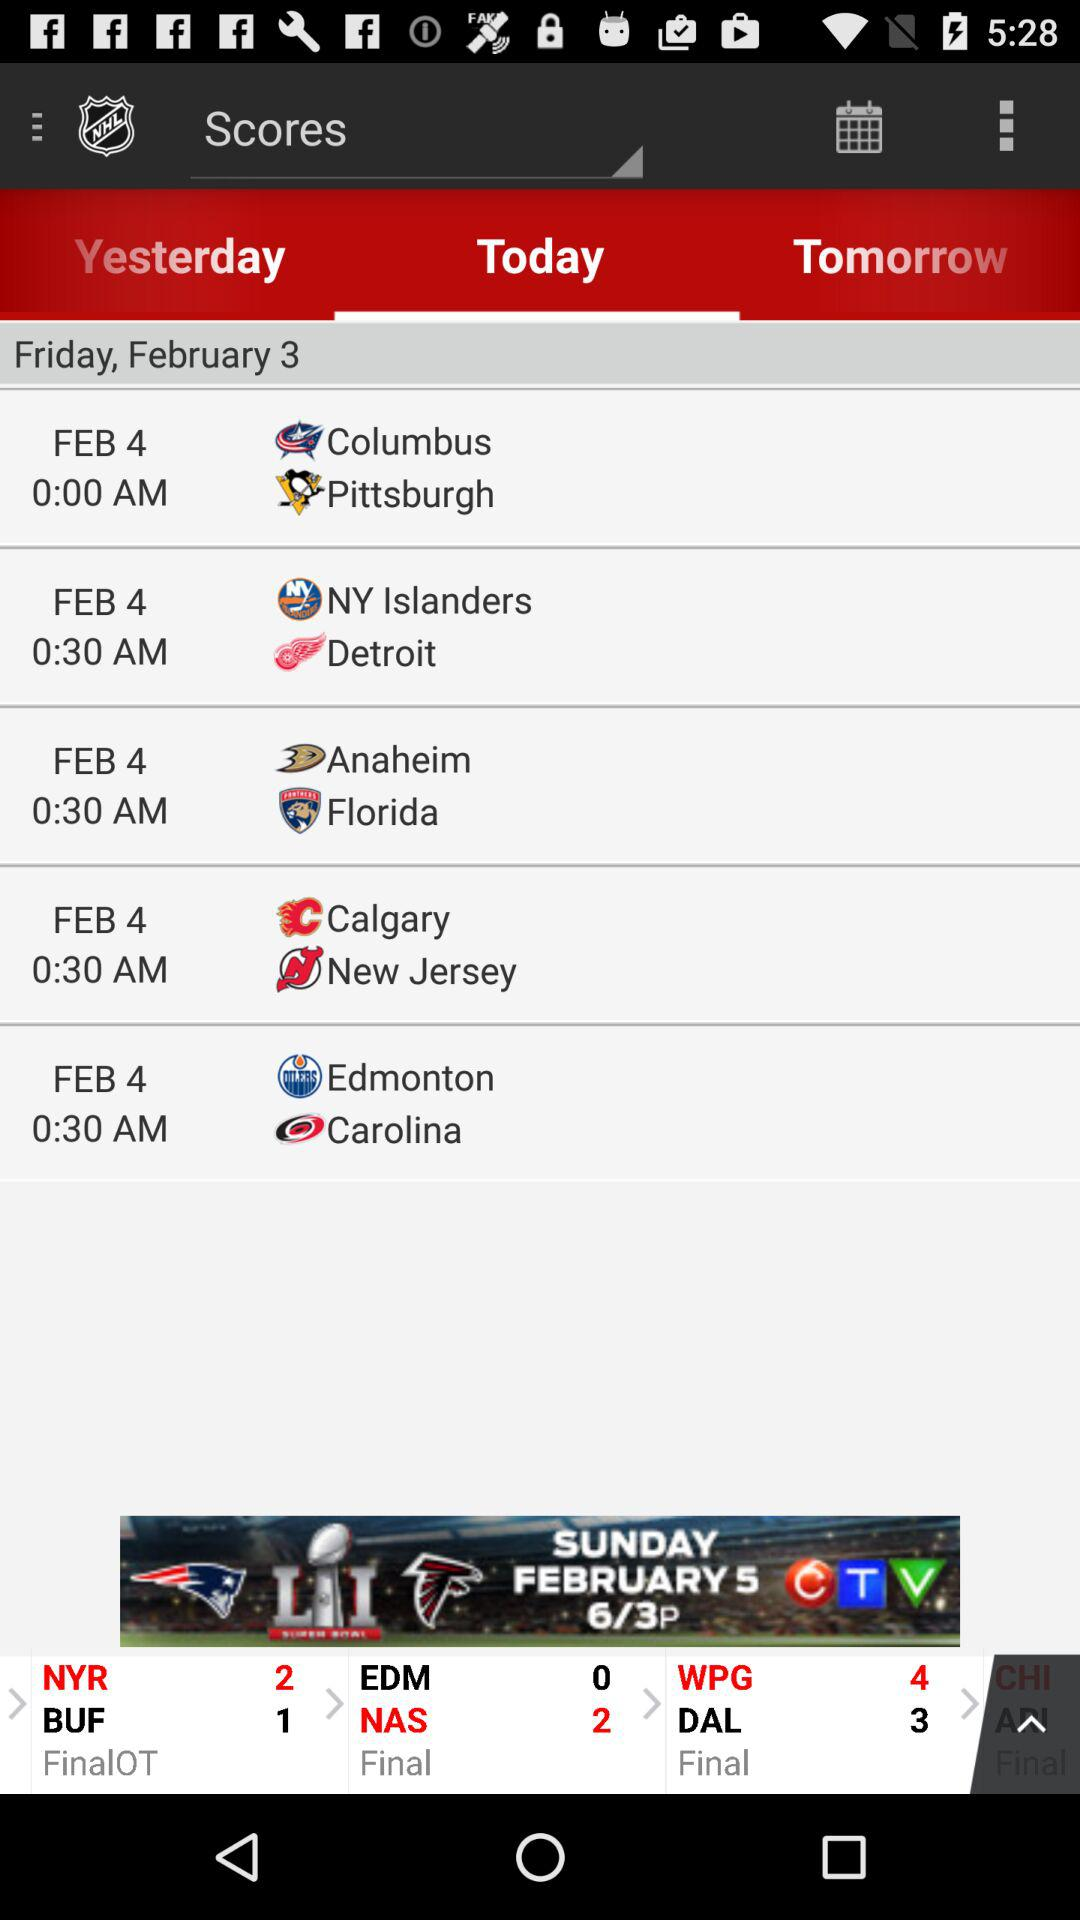What is the date of the match between Columbus and Pittsburgh? The date of the match is February 4. 